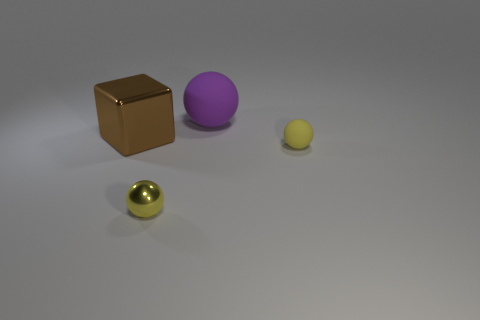Is the size of the yellow metallic object the same as the brown metallic thing? no 